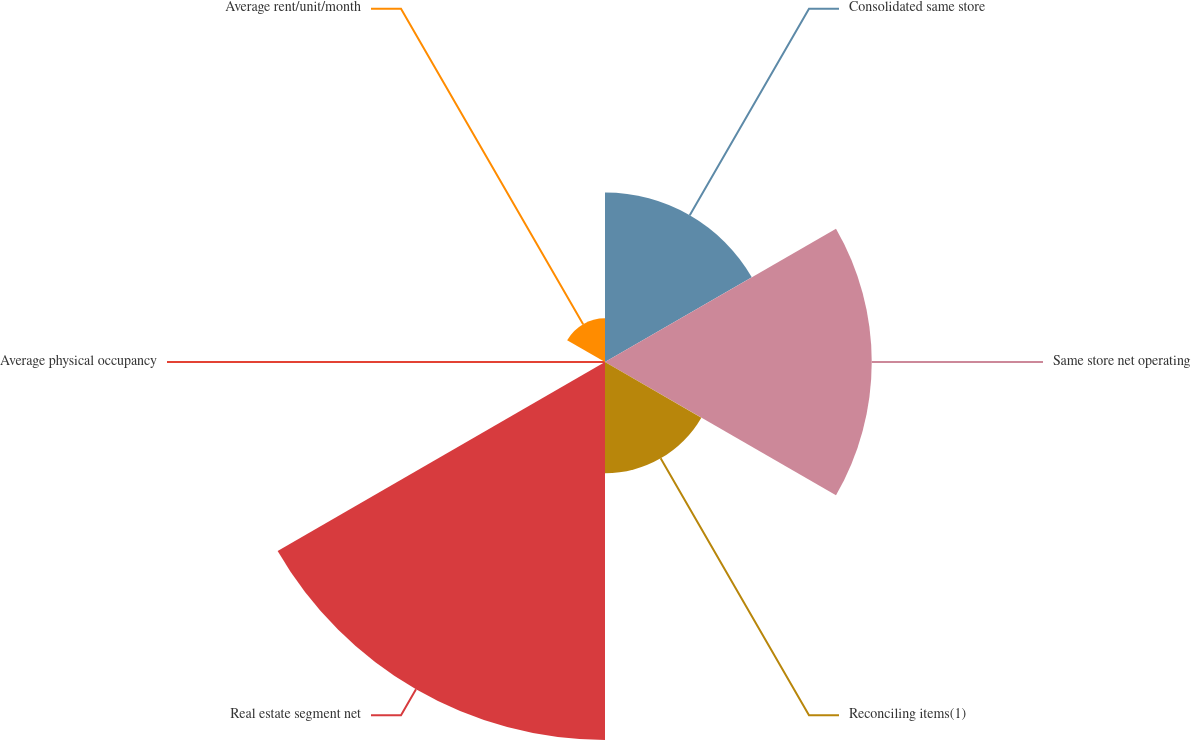Convert chart to OTSL. <chart><loc_0><loc_0><loc_500><loc_500><pie_chart><fcel>Consolidated same store<fcel>Same store net operating<fcel>Reconciling items(1)<fcel>Real estate segment net<fcel>Average physical occupancy<fcel>Average rent/unit/month<nl><fcel>17.49%<fcel>27.52%<fcel>11.48%<fcel>39.0%<fcel>0.01%<fcel>4.51%<nl></chart> 